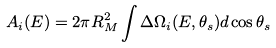Convert formula to latex. <formula><loc_0><loc_0><loc_500><loc_500>A _ { i } ( E ) = 2 \pi R _ { M } ^ { 2 } \int \Delta \Omega _ { i } ( E , \theta _ { s } ) d \cos \theta _ { s }</formula> 